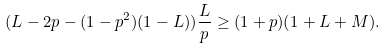<formula> <loc_0><loc_0><loc_500><loc_500>( L - 2 p - ( 1 - p ^ { 2 } ) ( 1 - L ) ) \frac { L } { p } \geq ( 1 + p ) ( 1 + L + M ) .</formula> 